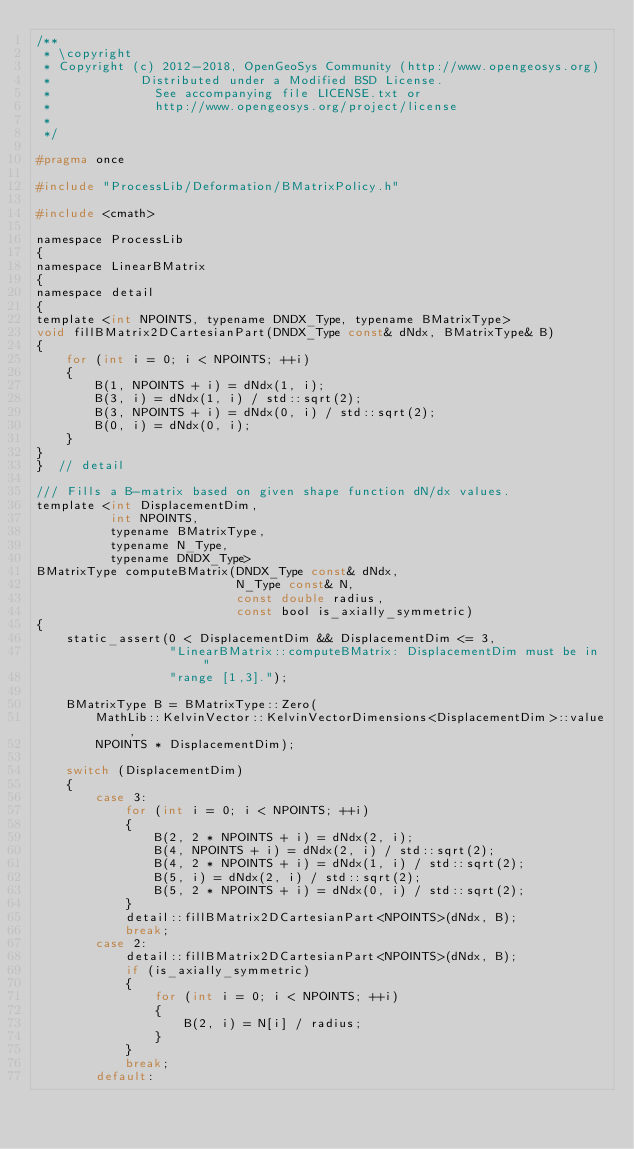<code> <loc_0><loc_0><loc_500><loc_500><_C_>/**
 * \copyright
 * Copyright (c) 2012-2018, OpenGeoSys Community (http://www.opengeosys.org)
 *            Distributed under a Modified BSD License.
 *              See accompanying file LICENSE.txt or
 *              http://www.opengeosys.org/project/license
 *
 */

#pragma once

#include "ProcessLib/Deformation/BMatrixPolicy.h"

#include <cmath>

namespace ProcessLib
{
namespace LinearBMatrix
{
namespace detail
{
template <int NPOINTS, typename DNDX_Type, typename BMatrixType>
void fillBMatrix2DCartesianPart(DNDX_Type const& dNdx, BMatrixType& B)
{
    for (int i = 0; i < NPOINTS; ++i)
    {
        B(1, NPOINTS + i) = dNdx(1, i);
        B(3, i) = dNdx(1, i) / std::sqrt(2);
        B(3, NPOINTS + i) = dNdx(0, i) / std::sqrt(2);
        B(0, i) = dNdx(0, i);
    }
}
}  // detail

/// Fills a B-matrix based on given shape function dN/dx values.
template <int DisplacementDim,
          int NPOINTS,
          typename BMatrixType,
          typename N_Type,
          typename DNDX_Type>
BMatrixType computeBMatrix(DNDX_Type const& dNdx,
                           N_Type const& N,
                           const double radius,
                           const bool is_axially_symmetric)
{
    static_assert(0 < DisplacementDim && DisplacementDim <= 3,
                  "LinearBMatrix::computeBMatrix: DisplacementDim must be in "
                  "range [1,3].");

    BMatrixType B = BMatrixType::Zero(
        MathLib::KelvinVector::KelvinVectorDimensions<DisplacementDim>::value,
        NPOINTS * DisplacementDim);

    switch (DisplacementDim)
    {
        case 3:
            for (int i = 0; i < NPOINTS; ++i)
            {
                B(2, 2 * NPOINTS + i) = dNdx(2, i);
                B(4, NPOINTS + i) = dNdx(2, i) / std::sqrt(2);
                B(4, 2 * NPOINTS + i) = dNdx(1, i) / std::sqrt(2);
                B(5, i) = dNdx(2, i) / std::sqrt(2);
                B(5, 2 * NPOINTS + i) = dNdx(0, i) / std::sqrt(2);
            }
            detail::fillBMatrix2DCartesianPart<NPOINTS>(dNdx, B);
            break;
        case 2:
            detail::fillBMatrix2DCartesianPart<NPOINTS>(dNdx, B);
            if (is_axially_symmetric)
            {
                for (int i = 0; i < NPOINTS; ++i)
                {
                    B(2, i) = N[i] / radius;
                }
            }
            break;
        default:</code> 